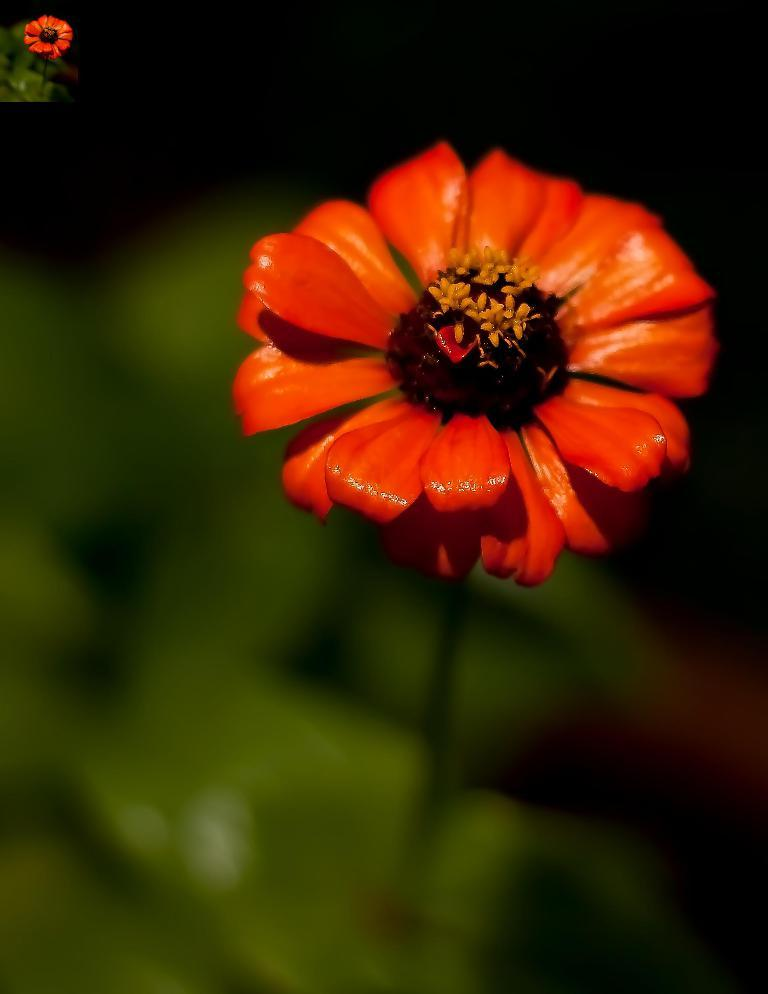What is the main subject of the image? There is a flower in the image. Can you hear the flower making any sounds in the image? Flowers do not make sounds, so there are no sounds to hear in the image. 